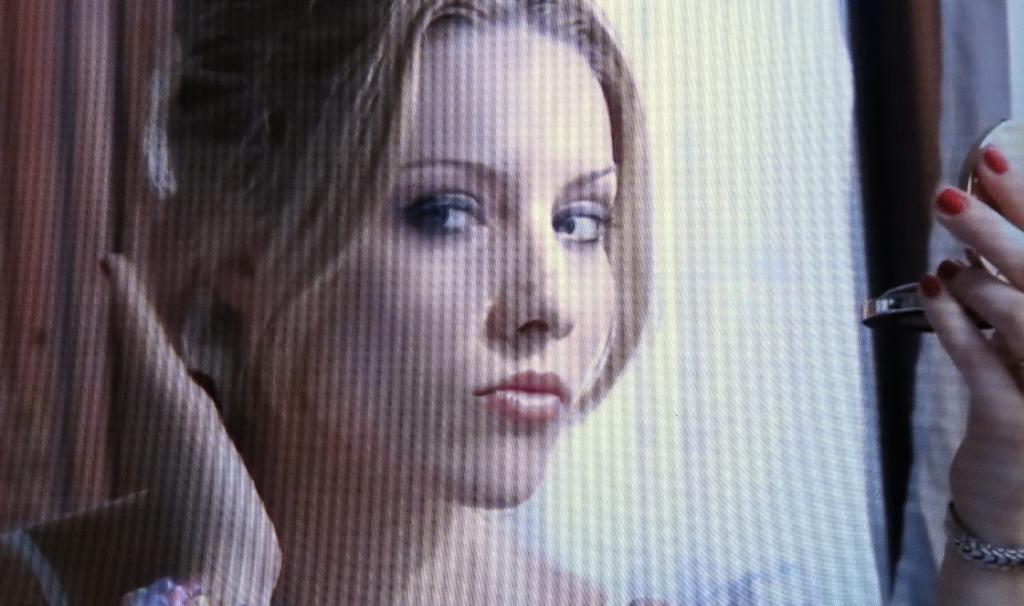Could you give a brief overview of what you see in this image? In this image we can see a woman holding a mirror with her left hand. 